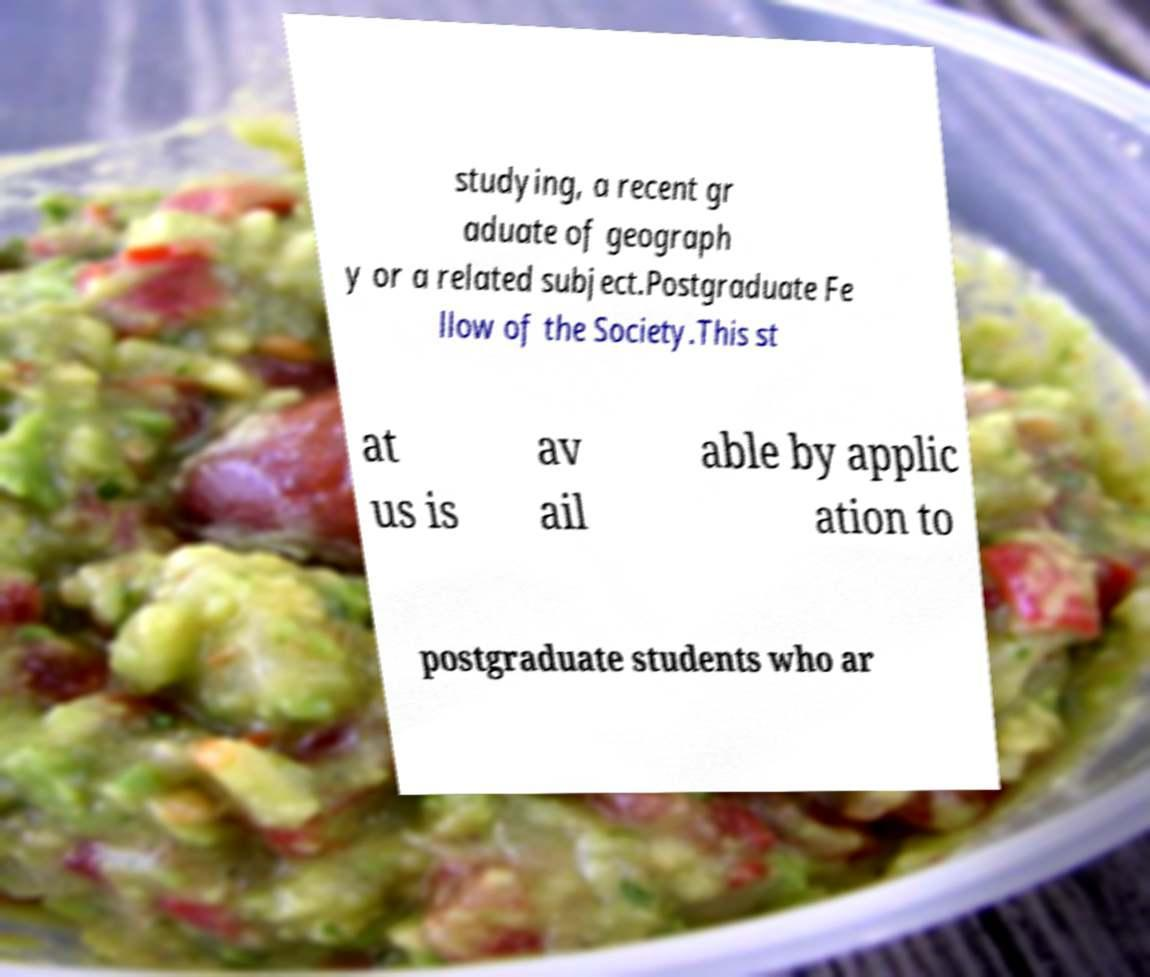Could you extract and type out the text from this image? studying, a recent gr aduate of geograph y or a related subject.Postgraduate Fe llow of the Society.This st at us is av ail able by applic ation to postgraduate students who ar 